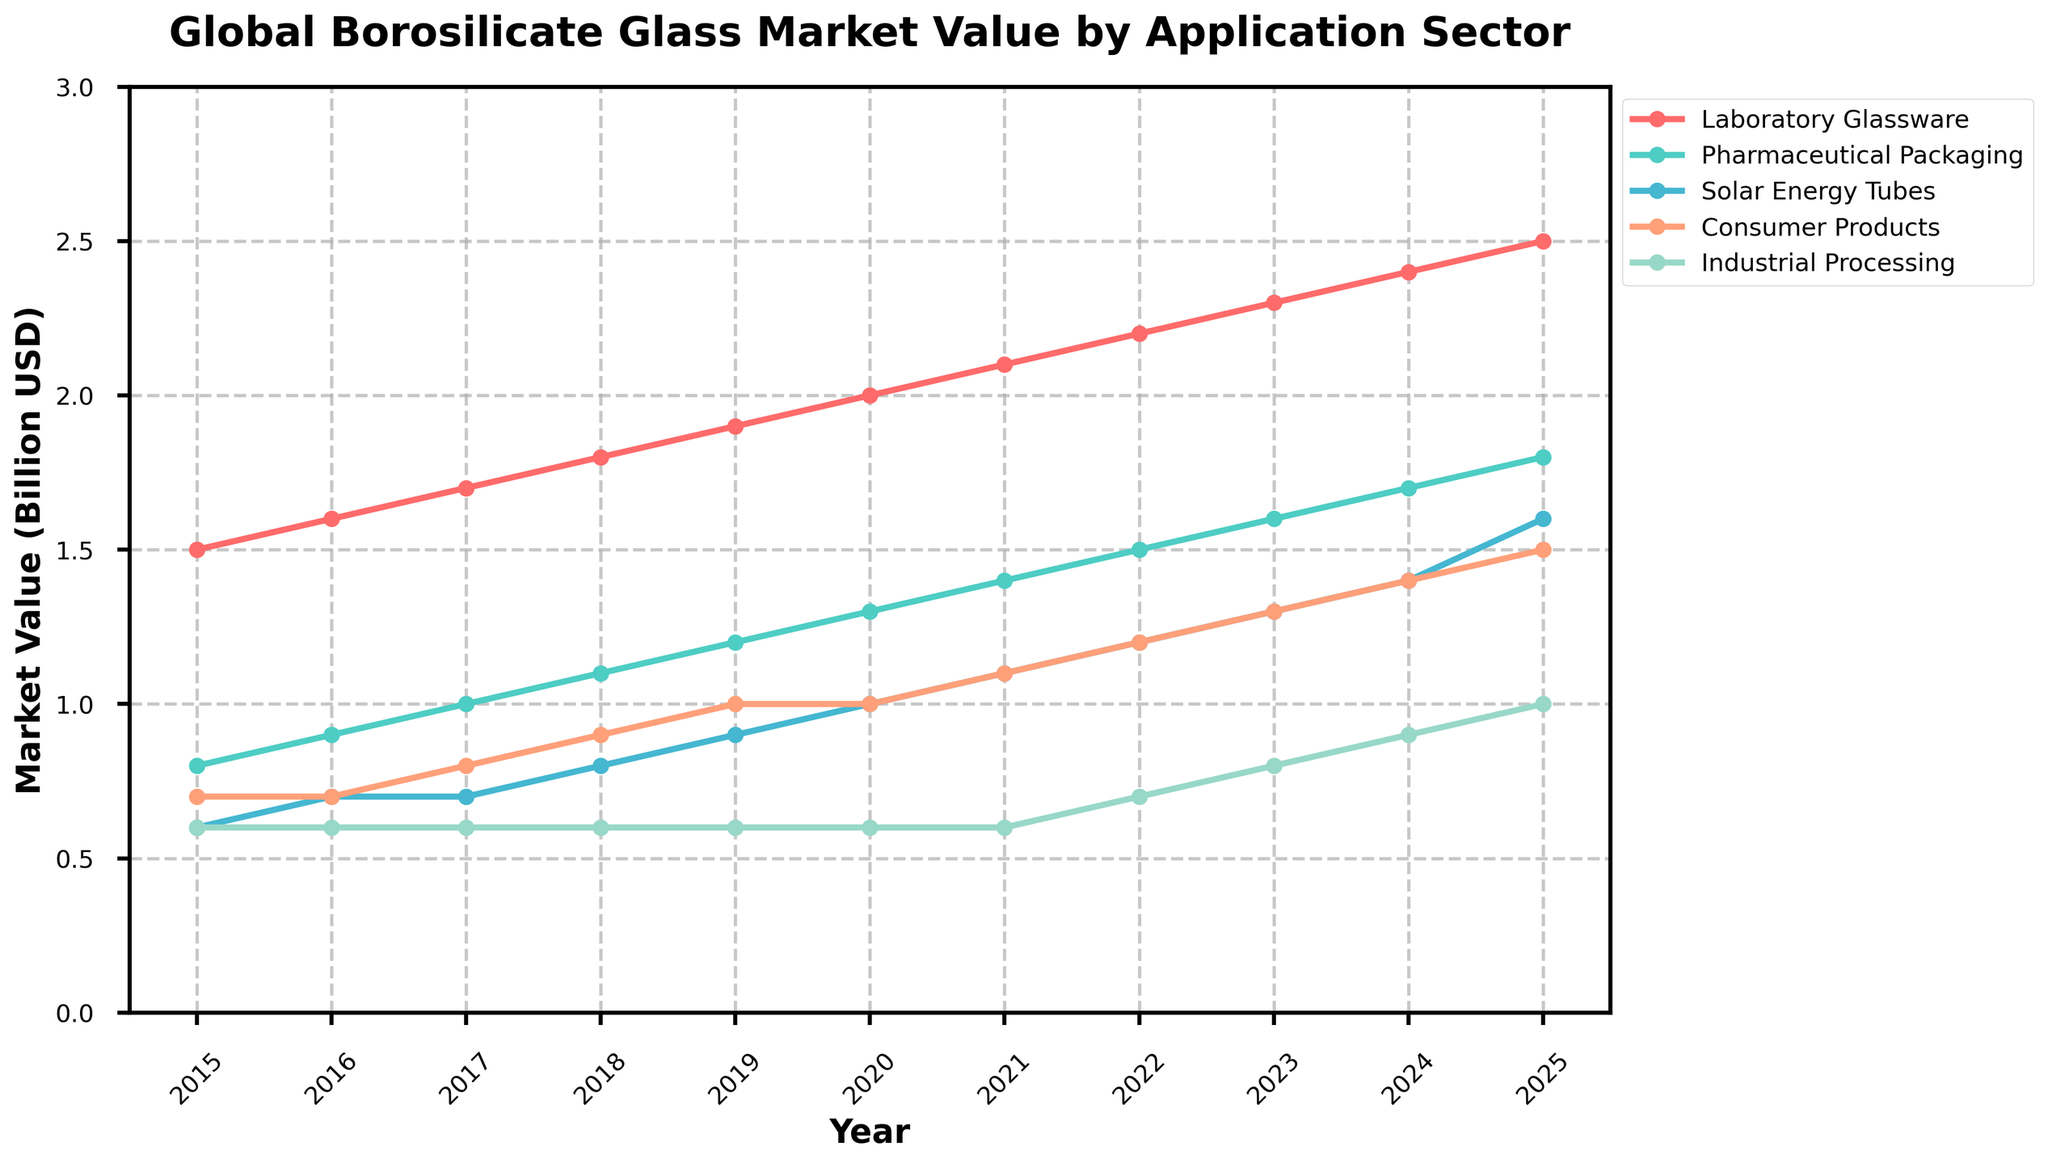What's the overall trend in the total market value of borosilicate glass from 2015 to 2025? Look at the line representing the total market value over the years. The line shows an upward trend, steadily increasing from 4.2 billion USD in 2015 to 8.4 billion USD in 2025.
Answer: Upward trend Which application sector had the highest market value in 2020? By observing the lines for different application sectors in 2020, the sector with the highest value reaches 2.0 billion USD. This corresponds to Laboratory Glassware.
Answer: Laboratory Glassware What is the difference in market value between Pharmaceutical Packaging and Solar Energy Tubes in 2023? In 2023, Pharmaceutical Packaging has a market value of 1.6 billion USD, and Solar Energy Tubes have 1.3 billion USD. Subtract the two values, 1.6 - 1.3 = 0.3 billion USD.
Answer: 0.3 billion USD Which sector shows the least growth from 2015 to 2025? Evaluate the lines for each sector from 2015 to 2025. Industrial Processing remains relatively constant, increasing only from 0.6 billion USD to 1.0 billion USD.
Answer: Industrial Processing What is the combined market value of Consumer Products and Industrial Processing in 2018? In 2018, Consumer Products have a market value of 0.9 billion USD, and Industrial Processing has 0.6 billion USD. Sum them up: 0.9 + 0.6 = 1.5 billion USD.
Answer: 1.5 billion USD Which application sector exhibits the most consistent growth over the years? Look for the line that shows the most even and steady increase from 2015 to 2025. Laboratory Glassware consistently grows each year from 1.5 billion USD to 2.5 billion USD.
Answer: Laboratory Glassware How much did the market value for Solar Energy Tubes change from 2019 to 2020? In 2019, the market value for Solar Energy Tubes is 0.9 billion USD, and it increases to 1.0 billion USD in 2020. The change is 1.0 - 0.9 = 0.1 billion USD.
Answer: 0.1 billion USD Compare the market value for Consumer Products in 2019 and 2025. By how much did it increase? In 2019, the market value for Consumer Products is 1.0 billion USD. In 2025, it rises to 1.5 billion USD. The increase is 1.5 - 1.0 = 0.5 billion USD.
Answer: 0.5 billion USD 